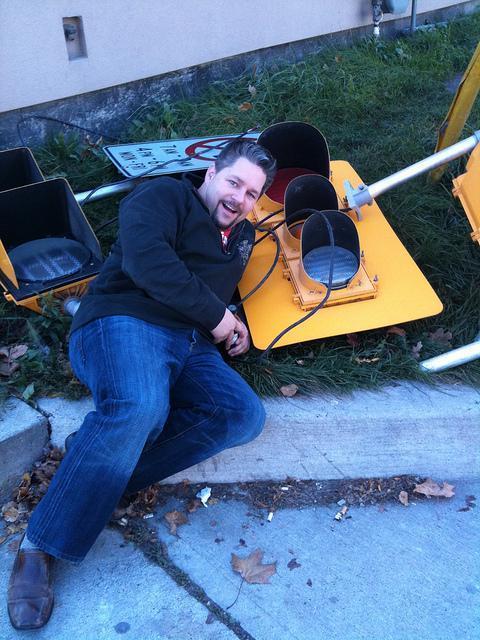How many traffic lights are in the photo?
Give a very brief answer. 2. 